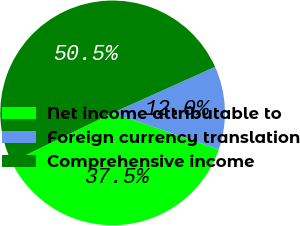Convert chart to OTSL. <chart><loc_0><loc_0><loc_500><loc_500><pie_chart><fcel>Net income attributable to<fcel>Foreign currency translation<fcel>Comprehensive income<nl><fcel>37.53%<fcel>11.99%<fcel>50.48%<nl></chart> 